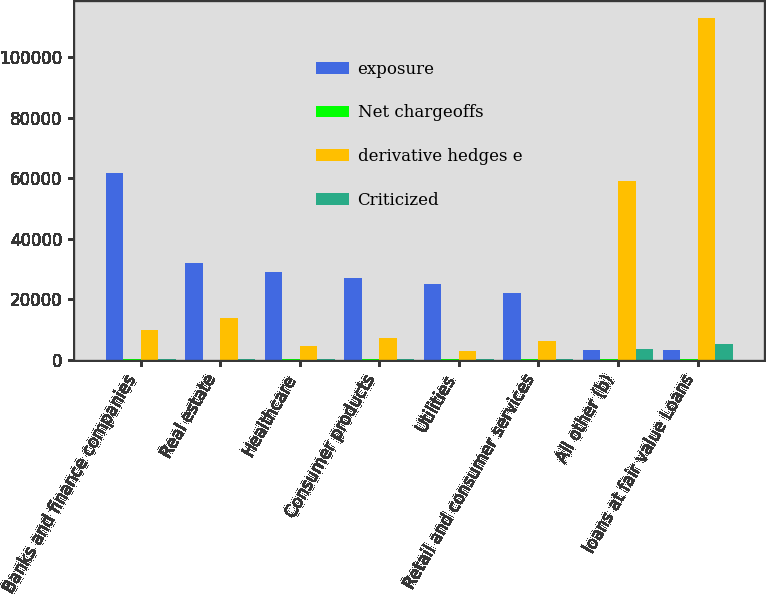Convert chart. <chart><loc_0><loc_0><loc_500><loc_500><stacked_bar_chart><ecel><fcel>Banks and finance companies<fcel>Real estate<fcel>Healthcare<fcel>Consumer products<fcel>Utilities<fcel>Retail and consumer services<fcel>All other (b)<fcel>loans at fair value Loans<nl><fcel>exposure<fcel>61792<fcel>32102<fcel>28998<fcel>27114<fcel>24938<fcel>22122<fcel>3206.5<fcel>3206.5<nl><fcel>Net chargeoffs<fcel>84<fcel>57<fcel>83<fcel>72<fcel>88<fcel>70<fcel>80<fcel>81<nl><fcel>derivative hedges e<fcel>9733<fcel>13702<fcel>4618<fcel>7327<fcel>2929<fcel>6268<fcel>58971<fcel>113049<nl><fcel>Criticized<fcel>74<fcel>243<fcel>284<fcel>383<fcel>183<fcel>278<fcel>3484<fcel>5026<nl></chart> 